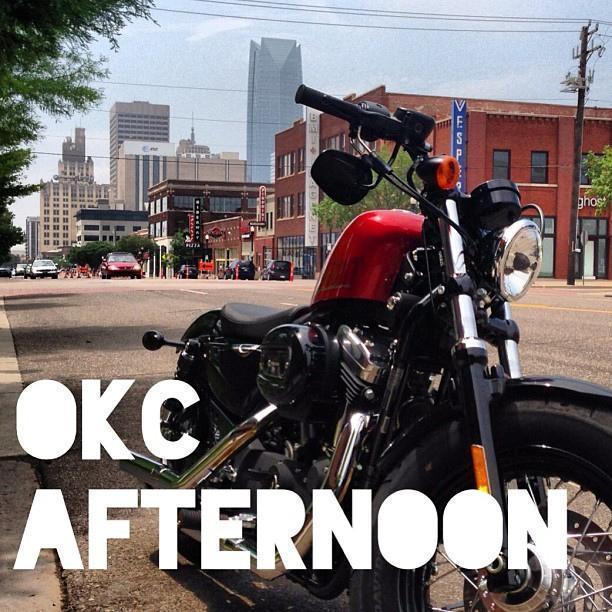What kind of building is the one with the black sign?
Choose the correct response and explain in the format: 'Answer: answer
Rationale: rationale.'
Options: Gym, restaurant, bank, hospital. Answer: restaurant.
Rationale: The place has a sign that says pizza and pizza is served at restaurants. 